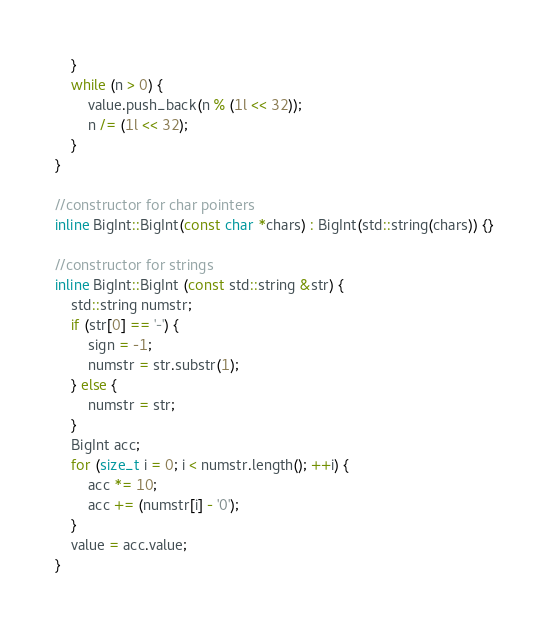Convert code to text. <code><loc_0><loc_0><loc_500><loc_500><_C++_>    }
    while (n > 0) {
        value.push_back(n % (1l << 32));
        n /= (1l << 32);
    }
}

//constructor for char pointers
inline BigInt::BigInt(const char *chars) : BigInt(std::string(chars)) {}

//constructor for strings
inline BigInt::BigInt (const std::string &str) {
    std::string numstr;
    if (str[0] == '-') {
        sign = -1;
        numstr = str.substr(1);
    } else {
        numstr = str;
    }
    BigInt acc;
    for (size_t i = 0; i < numstr.length(); ++i) {
        acc *= 10;
        acc += (numstr[i] - '0');
    }
    value = acc.value;
}</code> 